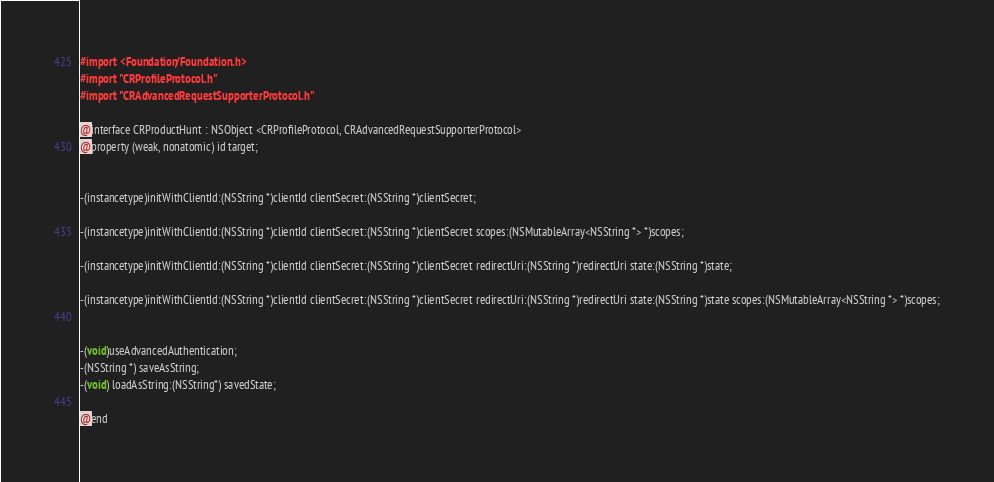<code> <loc_0><loc_0><loc_500><loc_500><_C_>
#import <Foundation/Foundation.h>
#import "CRProfileProtocol.h"
#import "CRAdvancedRequestSupporterProtocol.h"

@interface CRProductHunt : NSObject <CRProfileProtocol, CRAdvancedRequestSupporterProtocol>
@property (weak, nonatomic) id target;


-(instancetype)initWithClientId:(NSString *)clientId clientSecret:(NSString *)clientSecret;

-(instancetype)initWithClientId:(NSString *)clientId clientSecret:(NSString *)clientSecret scopes:(NSMutableArray<NSString *> *)scopes;

-(instancetype)initWithClientId:(NSString *)clientId clientSecret:(NSString *)clientSecret redirectUri:(NSString *)redirectUri state:(NSString *)state;

-(instancetype)initWithClientId:(NSString *)clientId clientSecret:(NSString *)clientSecret redirectUri:(NSString *)redirectUri state:(NSString *)state scopes:(NSMutableArray<NSString *> *)scopes;


-(void)useAdvancedAuthentication;
-(NSString *) saveAsString;
-(void) loadAsString:(NSString*) savedState;

@end
</code> 